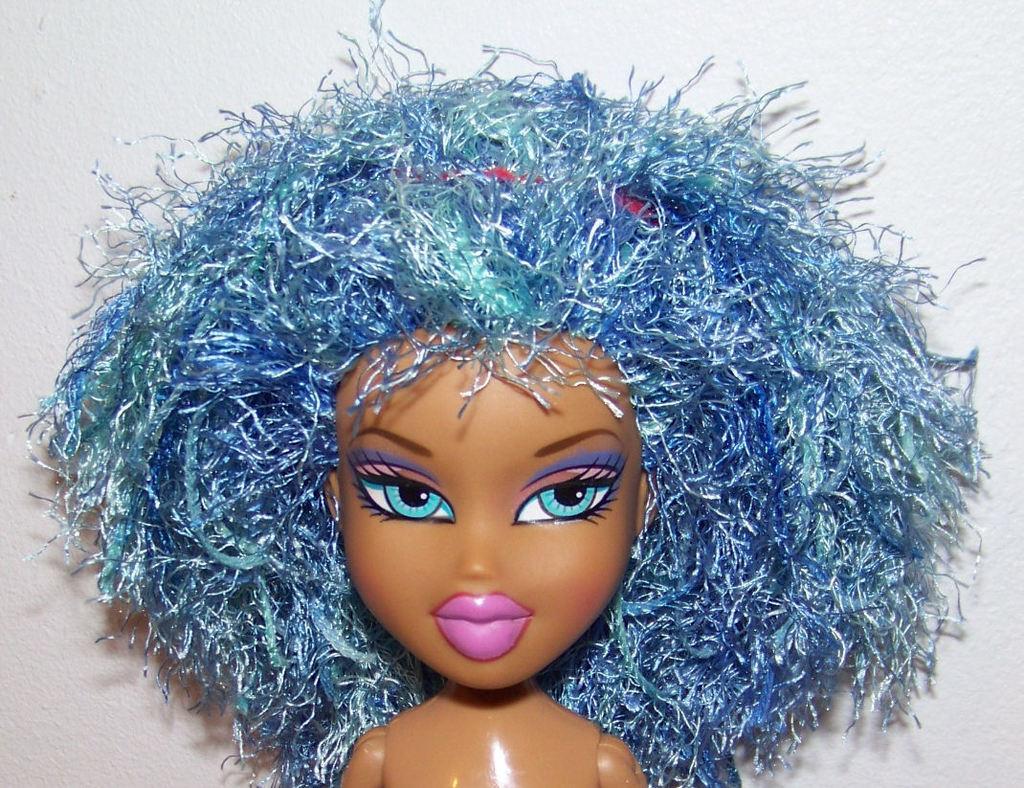Could you give a brief overview of what you see in this image? In this image we can see a doll. There is a white color background in the image. 